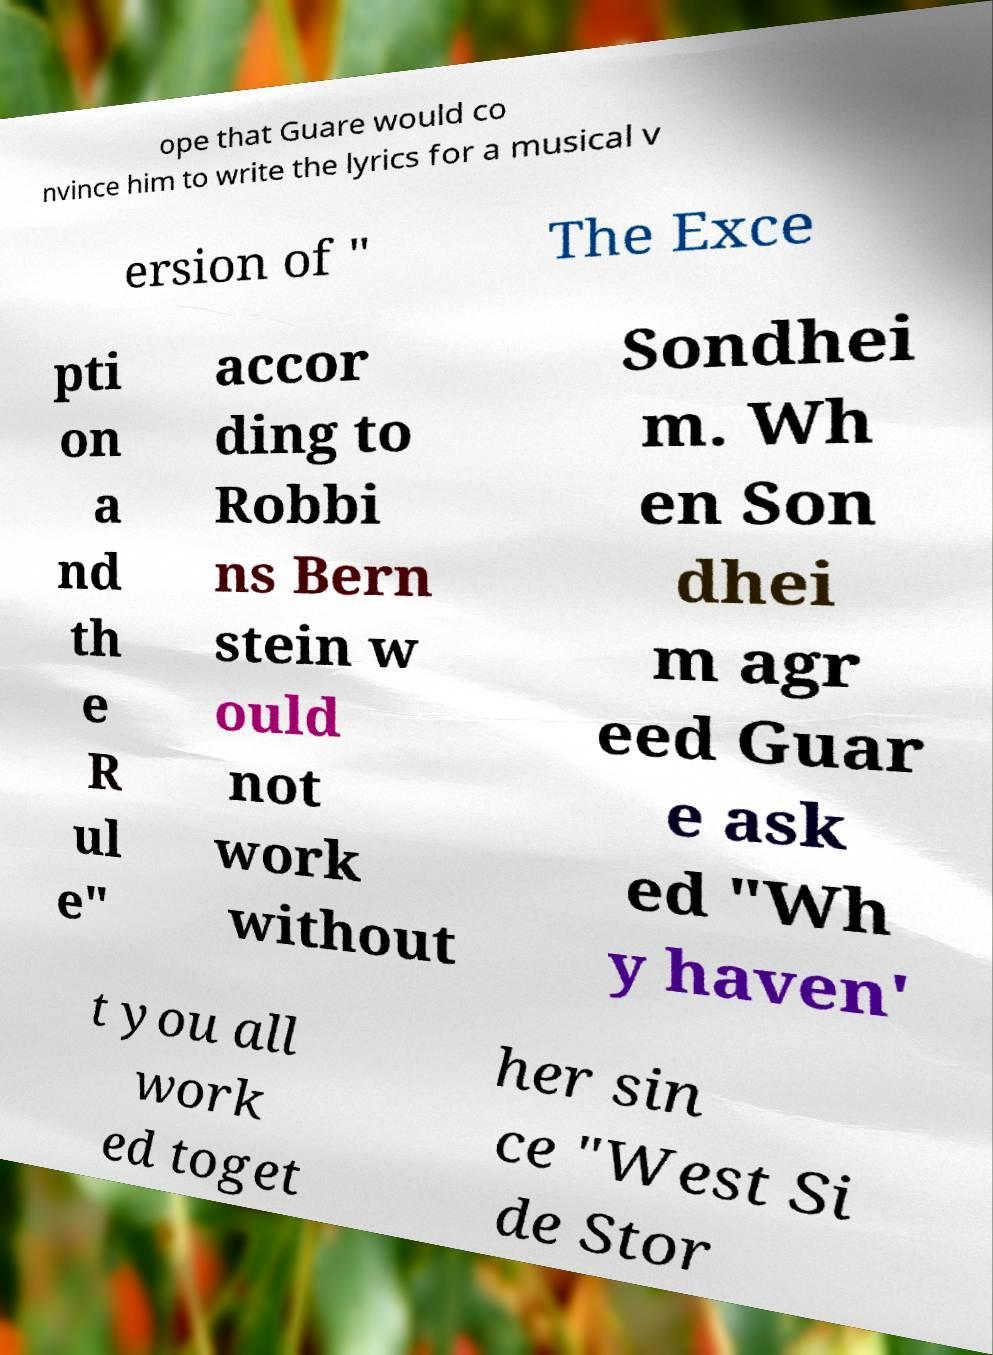Could you extract and type out the text from this image? ope that Guare would co nvince him to write the lyrics for a musical v ersion of " The Exce pti on a nd th e R ul e" accor ding to Robbi ns Bern stein w ould not work without Sondhei m. Wh en Son dhei m agr eed Guar e ask ed "Wh y haven' t you all work ed toget her sin ce "West Si de Stor 